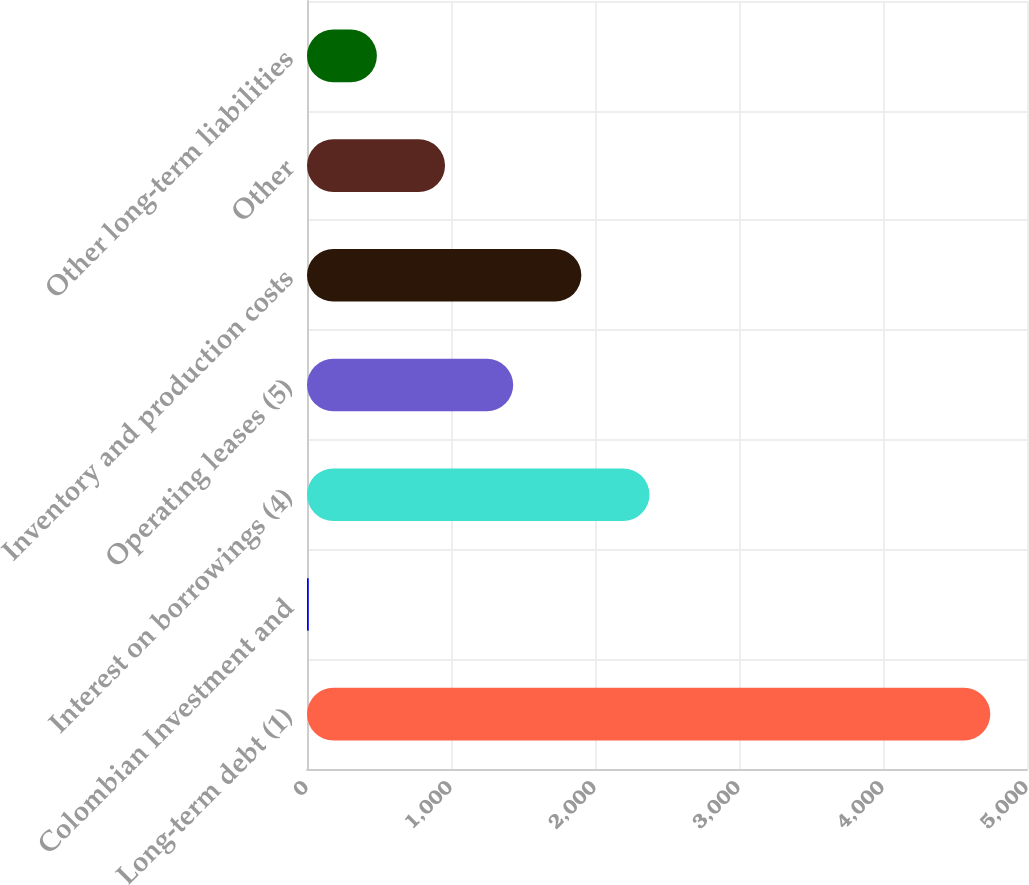Convert chart. <chart><loc_0><loc_0><loc_500><loc_500><bar_chart><fcel>Long-term debt (1)<fcel>Colombian Investment and<fcel>Interest on borrowings (4)<fcel>Operating leases (5)<fcel>Inventory and production costs<fcel>Other<fcel>Other long-term liabilities<nl><fcel>4745<fcel>12<fcel>2378.5<fcel>1431.9<fcel>1905.2<fcel>958.6<fcel>485.3<nl></chart> 